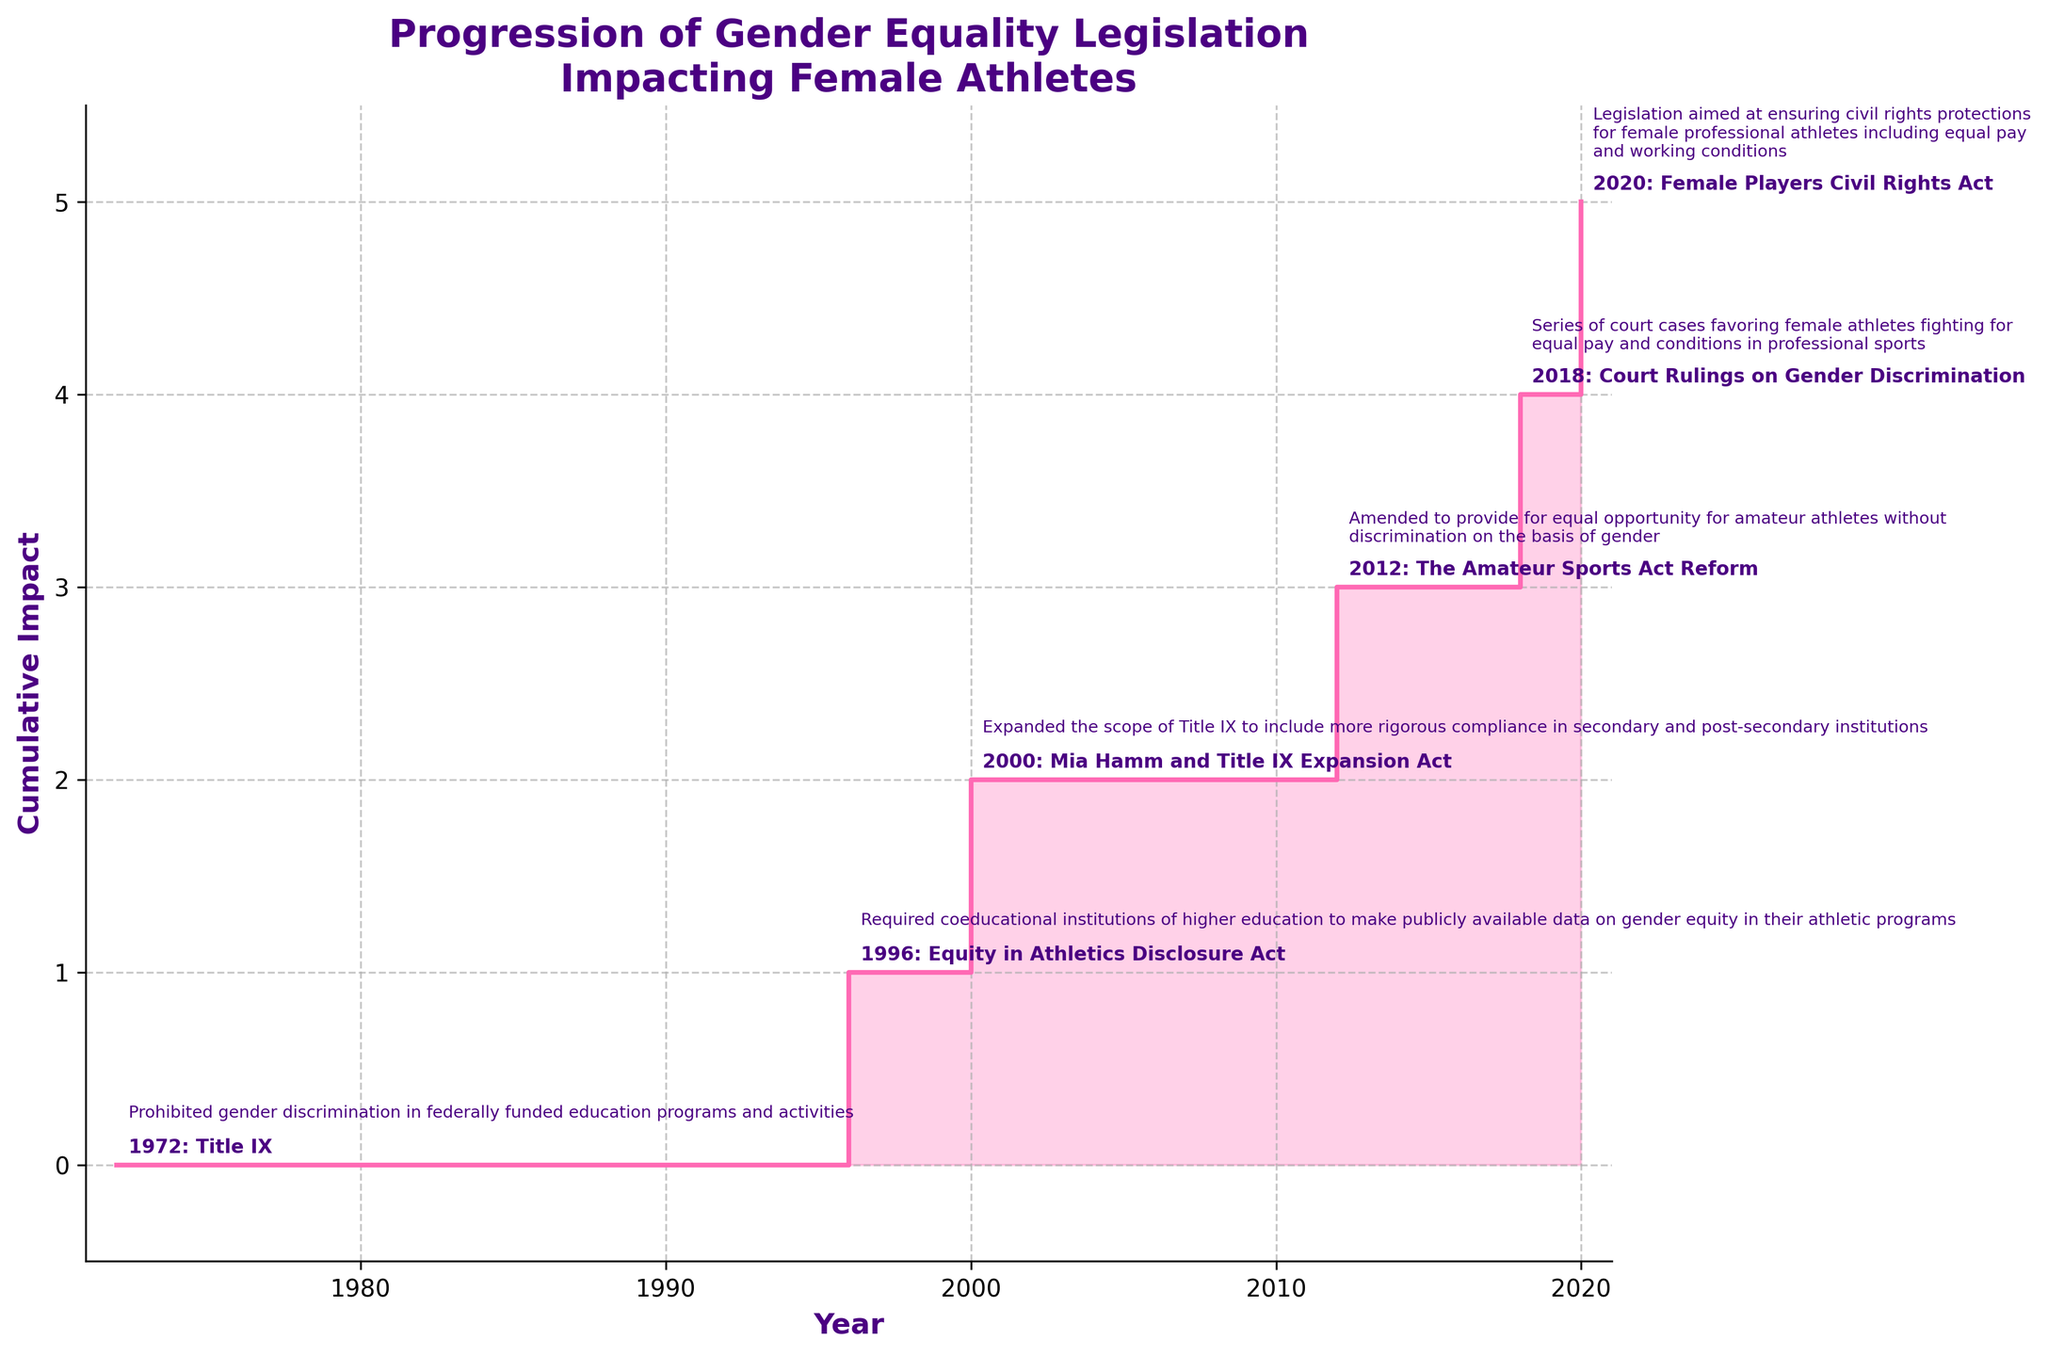What is the title of the chart? The title of the chart is located above the plot and can be read directly from the figure.
Answer: Progression of Gender Equality Legislation Impacting Female Athletes How many pieces of legislation are represented in the chart? By counting the distinct annotations on the chart, we can determine the number of legislations. Six pieces of legislation are annotated.
Answer: 6 In which year did the legislation with the most recent impact occur? By looking at the latest year annotated on the x-axis, we identify the most recent legislation.
Answer: 2020 Compare the impact between the 1972 and 1996 legislations: Which had a greater influence on its own according to the chart? By observing the step heights and annotations, the cumulative impact from 1972 has a greater influence compared to 1996.
Answer: 1972 How does the impact on female athletes change over time according to the chart? The cumulative impact on female athletes increases progressively with each legislation, as evidenced by the rising steps in the chart. This shows a positive trend towards gender equality.
Answer: Increases over time What year marked the start of increased legal backing for gender equality in professional sports? The impact annotation related to increased legal backing for gender equality in sports is marked at the year 2018.
Answer: 2018 Identify the legislation that focused on ensuring civil rights protections for female professional athletes including equal pay and working conditions? By referring to the annotations, the Female Players Civil Rights Act enacted in 2020 is focused on these aspects.
Answer: Female Players Civil Rights Act What is the general pattern observed in the impact of legislation over the years? The general pattern is a cumulative increase in positive impact on female athletes as each successive legislation is enacted. This results in a step-like increase in the impact area.
Answer: Cumulative increase Which legislation led to increased funding and attention for women's sports, and in what year was it enacted? The annotation for the year 2000 specifies that the Mia Hamm and Title IX Expansion Act led to increased funding and attention for women's sports.
Answer: Mia Hamm and Title IX Expansion Act, 2000 